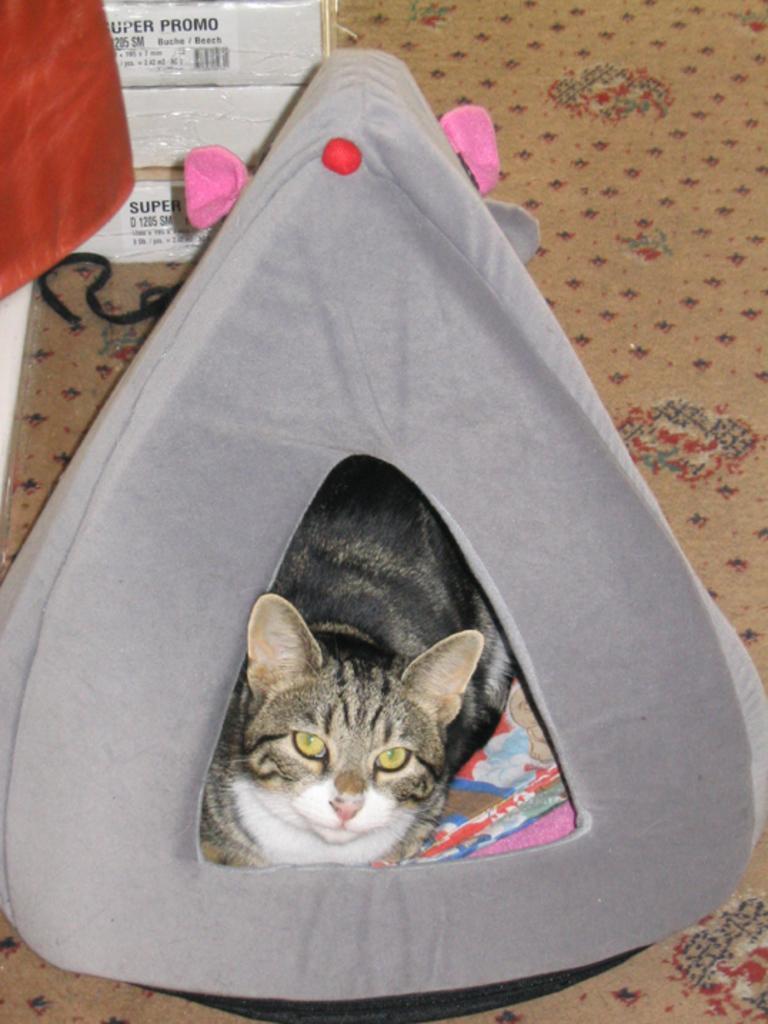Please provide a concise description of this image. In this image there is a cat inside the cat furniture in the center. In the background there are boxes which are white in colour and there are some text written on it. On the left side there is a curtain which is red in colour and on the floor there is a mat and on the mat there is black colour lace on the left side. 